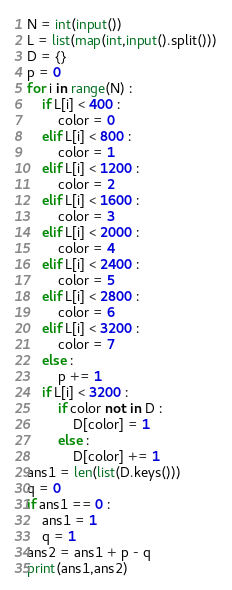<code> <loc_0><loc_0><loc_500><loc_500><_Python_>N = int(input())
L = list(map(int,input().split()))
D = {}
p = 0
for i in range(N) :
    if L[i] < 400 :
        color = 0
    elif L[i] < 800 :
        color = 1
    elif L[i] < 1200 :
        color = 2
    elif L[i] < 1600 :
        color = 3
    elif L[i] < 2000 :
        color = 4
    elif L[i] < 2400 :
        color = 5
    elif L[i] < 2800 :
        color = 6
    elif L[i] < 3200 :
        color = 7
    else :
        p += 1
    if L[i] < 3200 :
        if color not in D :
            D[color] = 1
        else :
            D[color] += 1
ans1 = len(list(D.keys()))
q = 0
if ans1 == 0 :
    ans1 = 1
    q = 1
ans2 = ans1 + p - q
print(ans1,ans2)
</code> 